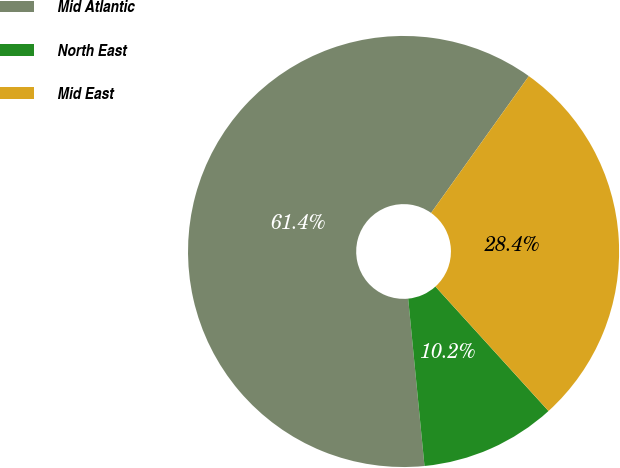<chart> <loc_0><loc_0><loc_500><loc_500><pie_chart><fcel>Mid Atlantic<fcel>North East<fcel>Mid East<nl><fcel>61.42%<fcel>10.19%<fcel>28.39%<nl></chart> 